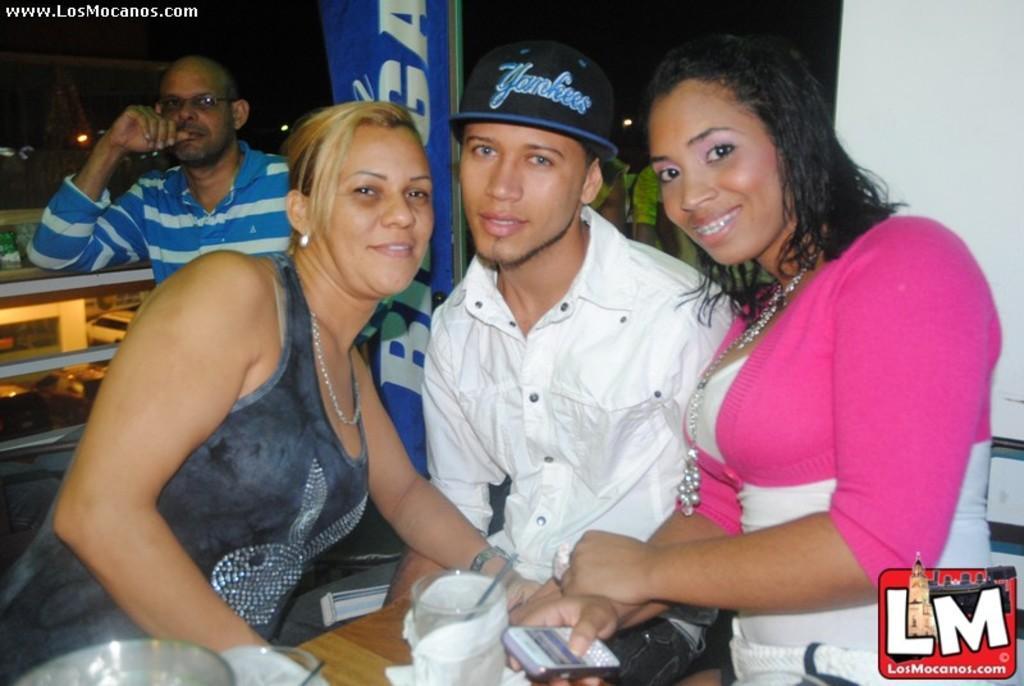In one or two sentences, can you explain what this image depicts? In front of the picture, we see two women and a man are sitting on the chairs. Three of them are smiling and they are posing for the photo. In front of them, we see a table on which glasses and tissue papers are placed. Behind them, we see a white wall and beside that, we see people are standing. The man on the left side is wearing the white and blue T-shirt. Behind him, we see a board in blue color with some text written on it. Beside him, we see the railing. In the background, we see the lights, buildings and the cars. 